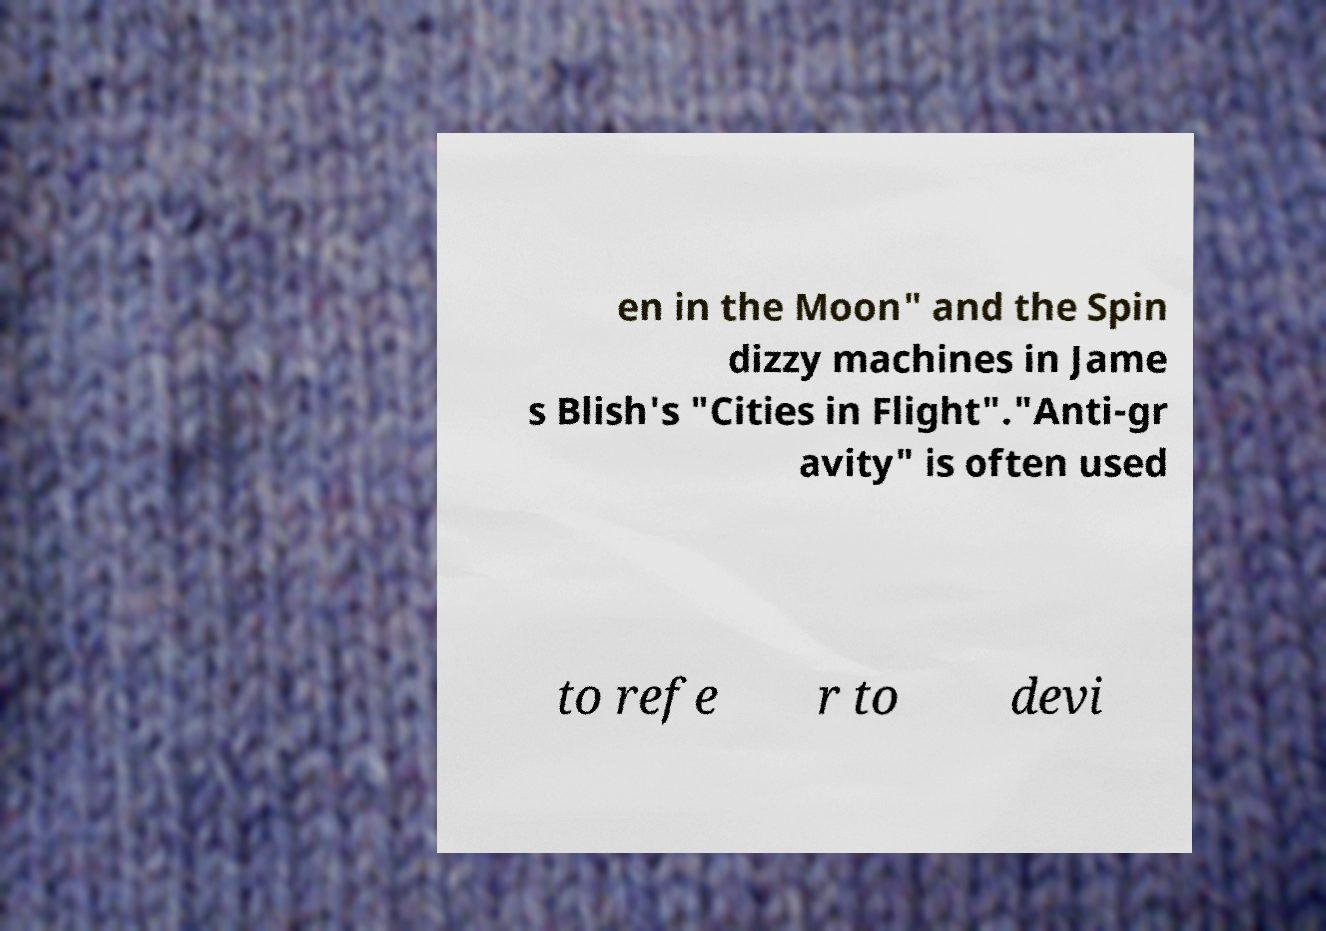There's text embedded in this image that I need extracted. Can you transcribe it verbatim? en in the Moon" and the Spin dizzy machines in Jame s Blish's "Cities in Flight"."Anti-gr avity" is often used to refe r to devi 